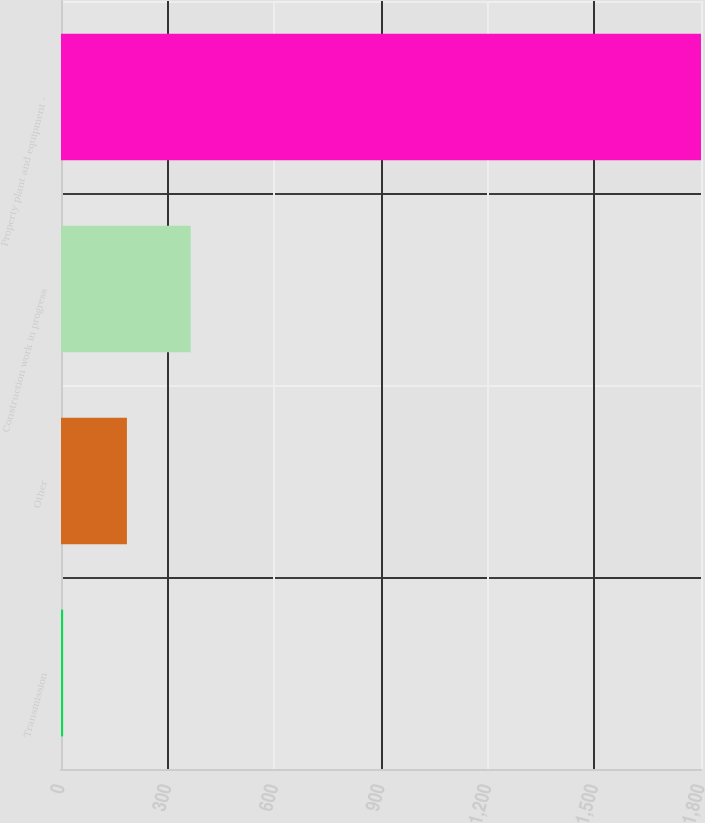Convert chart. <chart><loc_0><loc_0><loc_500><loc_500><bar_chart><fcel>Transmission<fcel>Other<fcel>Construction work in progress<fcel>Property plant and equipment -<nl><fcel>6<fcel>185.4<fcel>364.8<fcel>1800<nl></chart> 